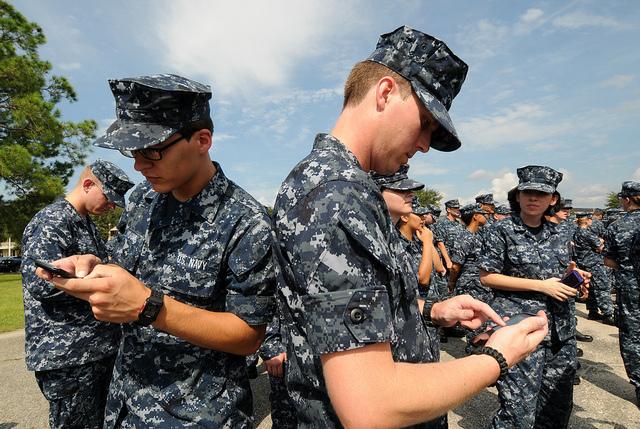How many people in uniform can be seen?
Be succinct. 16. Are the people in uniforms wearing hats?
Be succinct. Yes. What are the two policemen doing?
Short answer required. Texting. 